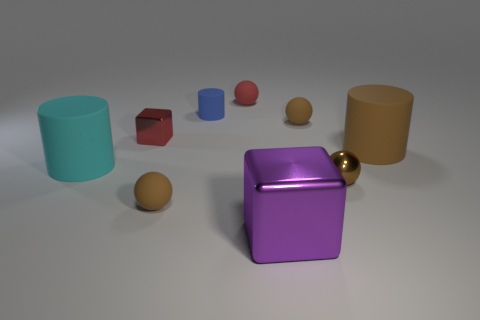What is the material of the small blue object?
Make the answer very short. Rubber. Do the purple shiny object and the blue thing have the same shape?
Your answer should be very brief. No. Are there any blue objects made of the same material as the red ball?
Provide a succinct answer. Yes. What color is the rubber cylinder that is to the left of the metal sphere and in front of the tiny metallic cube?
Give a very brief answer. Cyan. There is a tiny red thing left of the small matte cylinder; what is its material?
Your answer should be very brief. Metal. Is there a small blue shiny thing that has the same shape as the cyan thing?
Provide a succinct answer. No. What number of other things are the same shape as the brown metallic object?
Your answer should be very brief. 3. Does the purple metallic thing have the same shape as the small metallic thing that is to the right of the tiny red cube?
Your answer should be very brief. No. Are there any other things that are the same material as the tiny cylinder?
Provide a short and direct response. Yes. What is the material of the large brown object that is the same shape as the large cyan object?
Provide a short and direct response. Rubber. 